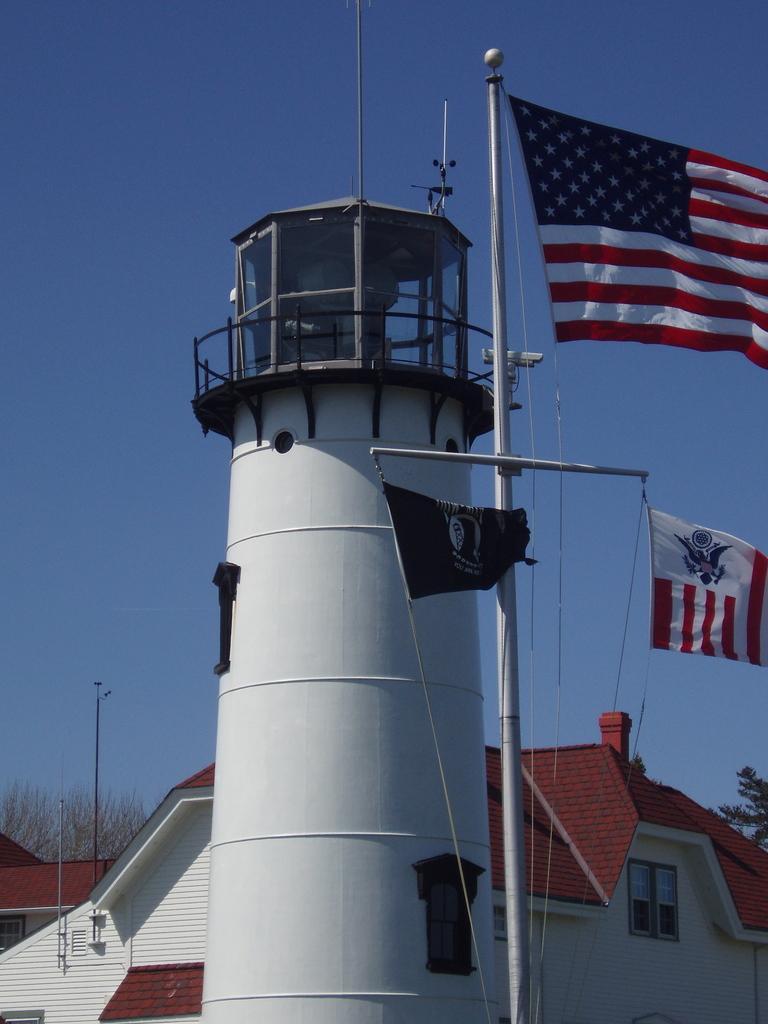Describe this image in one or two sentences. As we can see in the image there are buildings, houses, red color rooftops, trees, flags and sky. 